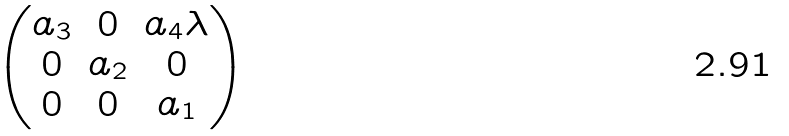<formula> <loc_0><loc_0><loc_500><loc_500>\begin{pmatrix} a _ { 3 } & 0 & a _ { 4 } \lambda \\ 0 & a _ { 2 } & 0 \\ 0 & 0 & a _ { 1 } \\ \end{pmatrix}</formula> 